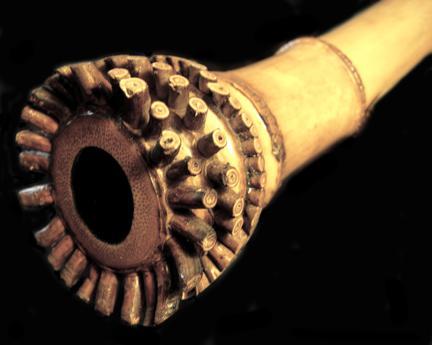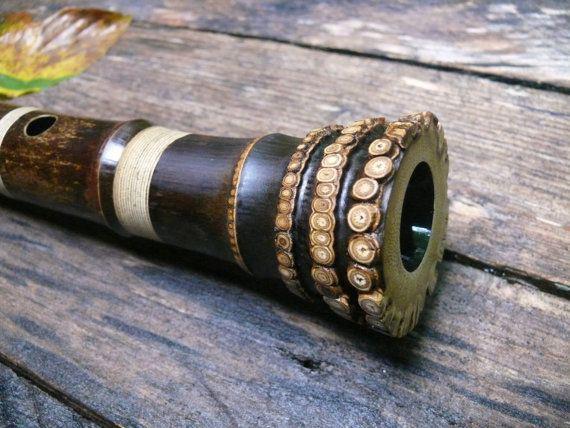The first image is the image on the left, the second image is the image on the right. Assess this claim about the two images: "there is a dark satined wood flute on a wooden table with a multicolored leaf on it". Correct or not? Answer yes or no. Yes. 